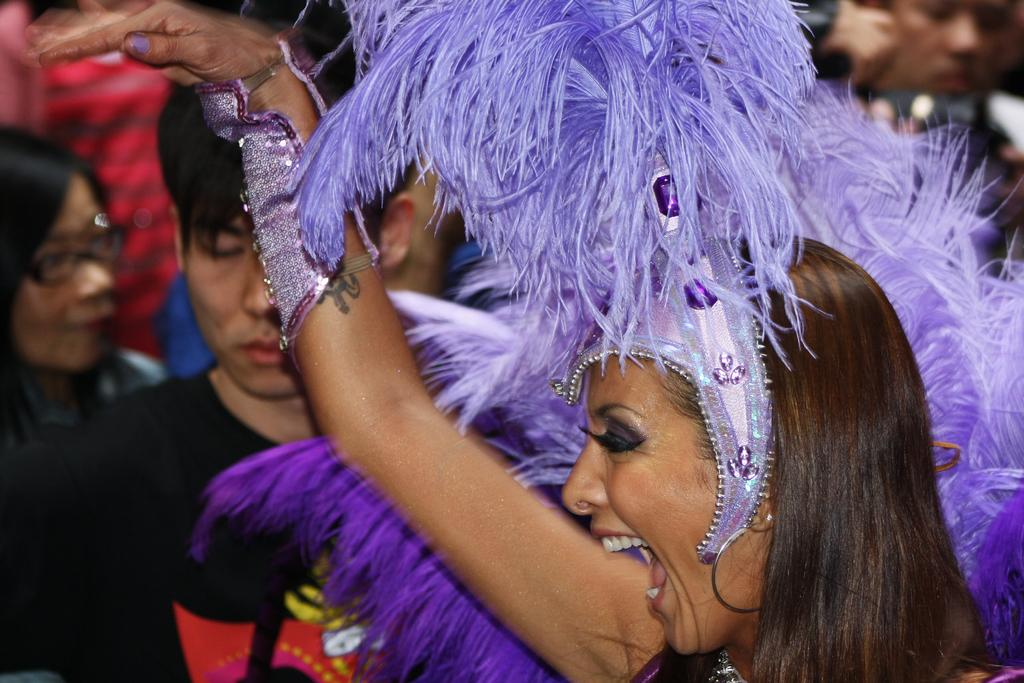What is the woman on the right side of the image doing? The woman is performing on the right side of the image. Can you describe the other persons in the image? There are other persons in the background of the image. What type of fuel is the woman using to perform in the image? There is no mention of fuel in the image, as it features a woman performing and other persons in the background. 